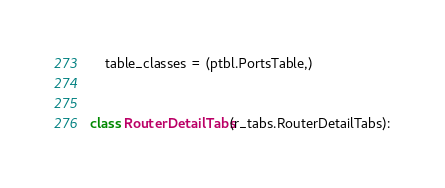<code> <loc_0><loc_0><loc_500><loc_500><_Python_>    table_classes = (ptbl.PortsTable,)


class RouterDetailTabs(r_tabs.RouterDetailTabs):</code> 